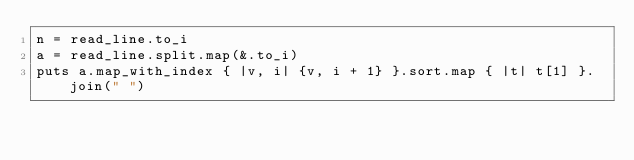<code> <loc_0><loc_0><loc_500><loc_500><_Crystal_>n = read_line.to_i
a = read_line.split.map(&.to_i)
puts a.map_with_index { |v, i| {v, i + 1} }.sort.map { |t| t[1] }.join(" ")
</code> 